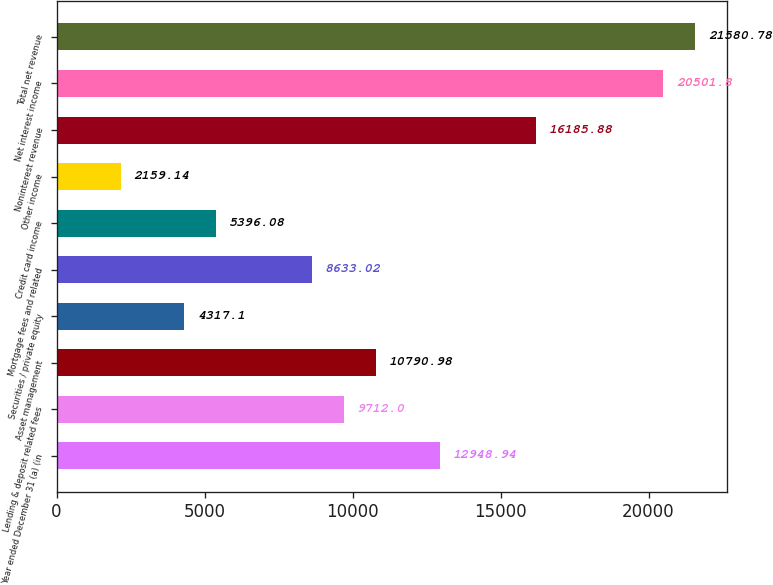Convert chart. <chart><loc_0><loc_0><loc_500><loc_500><bar_chart><fcel>Year ended December 31 (a) (in<fcel>Lending & deposit related fees<fcel>Asset management<fcel>Securities / private equity<fcel>Mortgage fees and related<fcel>Credit card income<fcel>Other income<fcel>Noninterest revenue<fcel>Net interest income<fcel>Total net revenue<nl><fcel>12948.9<fcel>9712<fcel>10791<fcel>4317.1<fcel>8633.02<fcel>5396.08<fcel>2159.14<fcel>16185.9<fcel>20501.8<fcel>21580.8<nl></chart> 